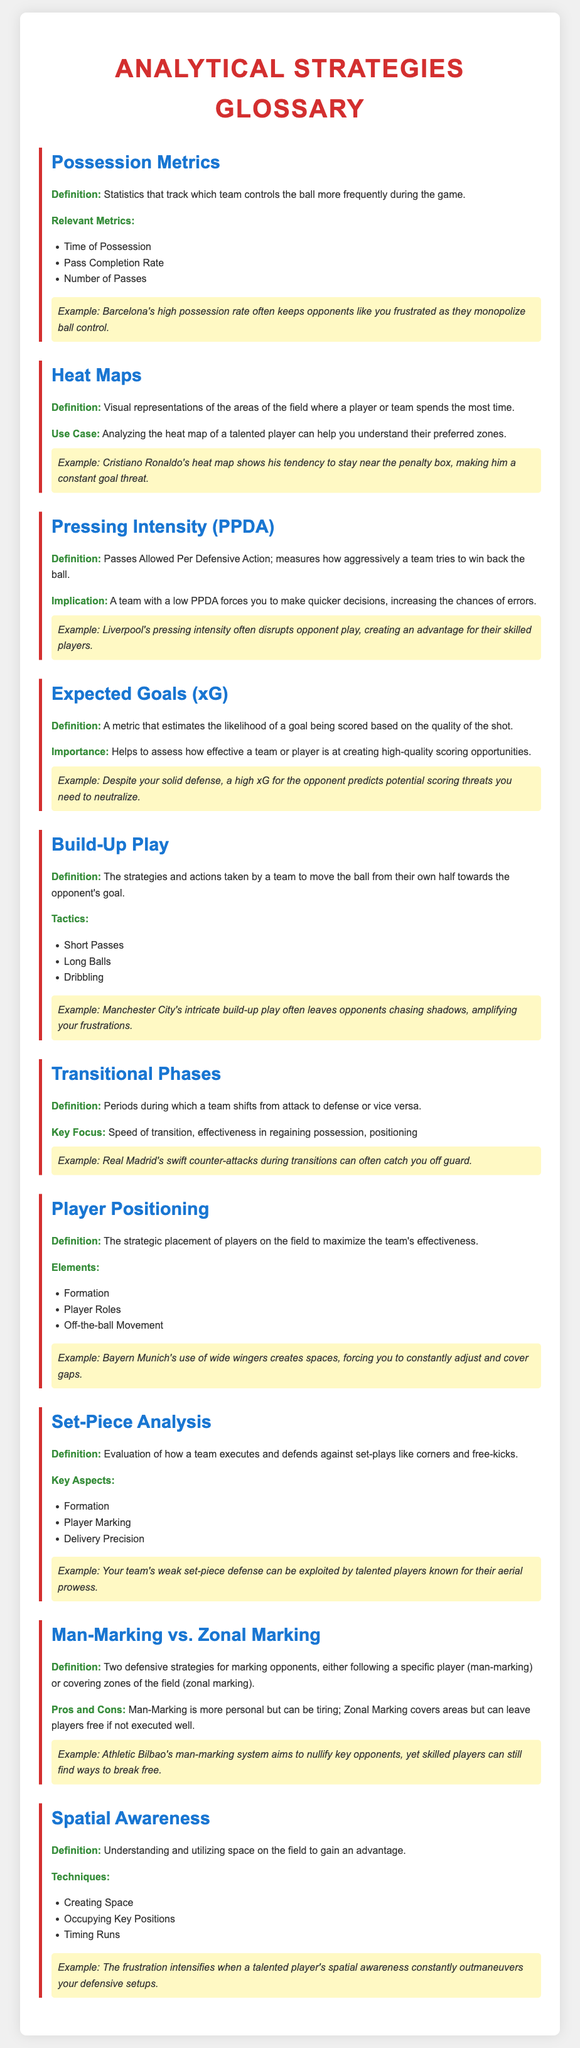What are Possession Metrics? Possession Metrics are statistics that track which team controls the ball more frequently during the game.
Answer: statistics for ball control What does PPDA stand for? PPDA stands for Passes Allowed Per Defensive Action.
Answer: Passes Allowed Per Defensive Action What example is given for Heat Maps? The example given for Heat Maps is Cristiano Ronaldo's heat map showing his tendency to stay near the penalty box.
Answer: Cristiano Ronaldo's heat map What is the Definition of Set-Piece Analysis? Set-Piece Analysis is the evaluation of how a team executes and defends against set-plays like corners and free-kicks.
Answer: evaluation of set-plays Why are pressing teams difficult to play against? Pressing teams are difficult to play against because they force quicker decisions, increasing the chances of errors.
Answer: quicker decisions and errors What do Build-Up Play tactics include? Build-Up Play tactics include Short Passes, Long Balls, and Dribbling.
Answer: Short Passes, Long Balls, and Dribbling How does Spatial Awareness benefit a player? Spatial Awareness benefits a player by helping them understand and utilize space on the field to gain an advantage.
Answer: understanding and utilizing space What are the two defensive strategies mentioned? The two defensive strategies mentioned are Man-Marking and Zonal Marking.
Answer: Man-Marking and Zonal Marking What is the key focus during Transitional Phases? The key focus during Transitional Phases is speed of transition, effectiveness in regaining possession, and positioning.
Answer: speed of transition and positioning 